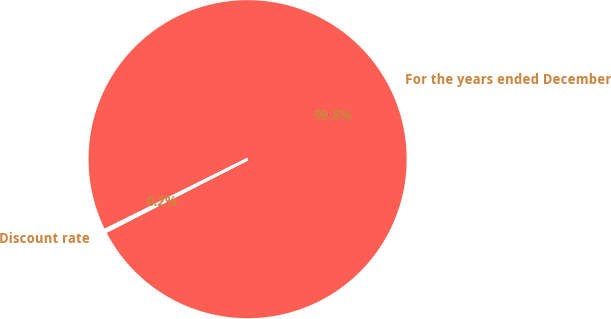Convert chart. <chart><loc_0><loc_0><loc_500><loc_500><pie_chart><fcel>For the years ended December<fcel>Discount rate<nl><fcel>99.79%<fcel>0.21%<nl></chart> 